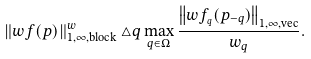Convert formula to latex. <formula><loc_0><loc_0><loc_500><loc_500>\left \| w f ( p ) \right \| _ { 1 , \infty , \text {block} } ^ { w } \triangle q \max _ { q \in \Omega } \frac { \left \| w f _ { _ { q } } ( p _ { - q } ) \right \| _ { 1 , \infty , \text {vec} } } { w _ { q } } . \text { }</formula> 